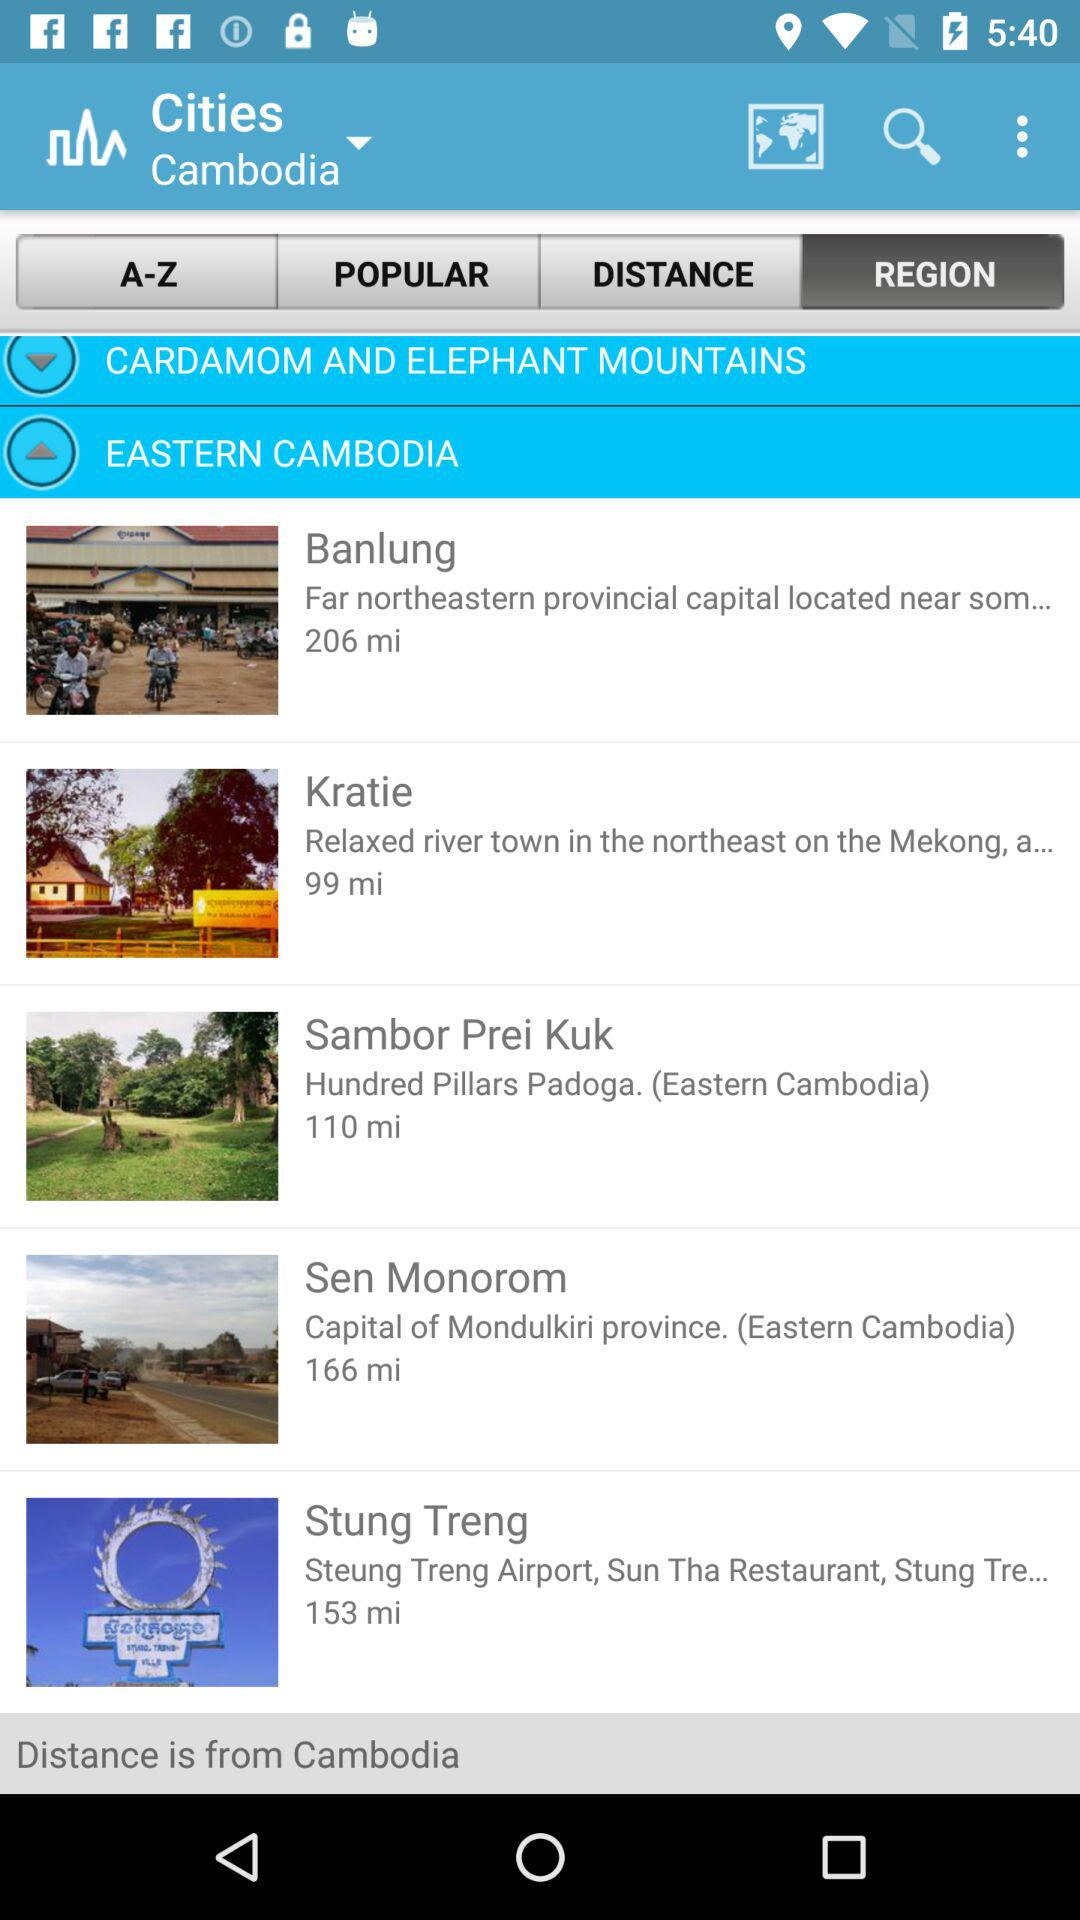What is the distance of Banlung from Cambodia? The distance is 206 miles. 